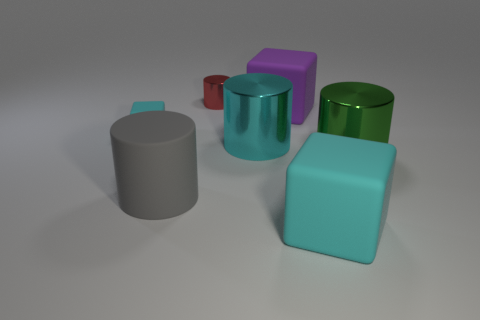Add 3 big matte cylinders. How many objects exist? 10 Subtract all cylinders. How many objects are left? 3 Add 4 tiny rubber things. How many tiny rubber things exist? 5 Subtract 1 gray cylinders. How many objects are left? 6 Subtract all large cubes. Subtract all small metal cylinders. How many objects are left? 4 Add 7 cyan rubber cubes. How many cyan rubber cubes are left? 9 